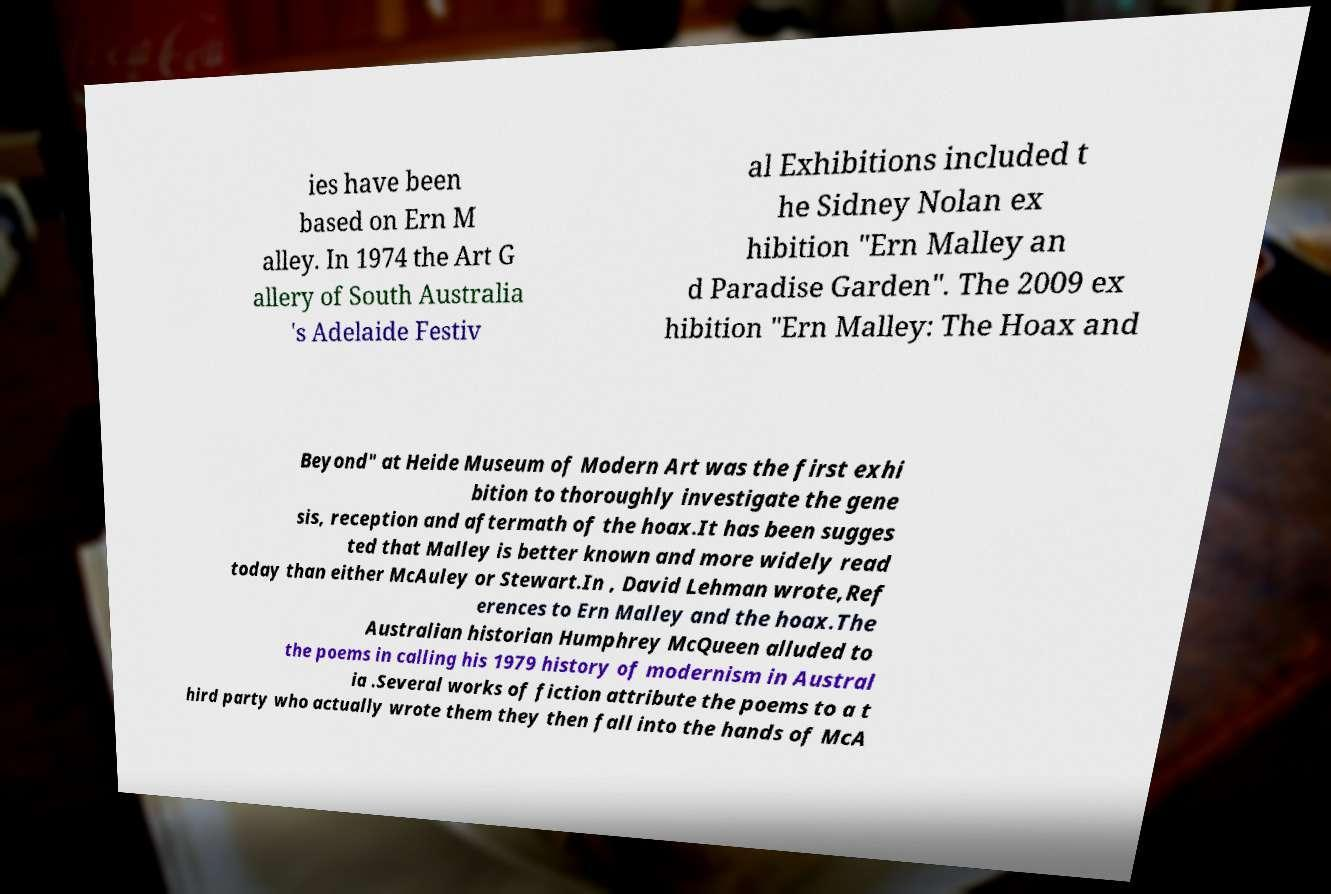There's text embedded in this image that I need extracted. Can you transcribe it verbatim? ies have been based on Ern M alley. In 1974 the Art G allery of South Australia 's Adelaide Festiv al Exhibitions included t he Sidney Nolan ex hibition "Ern Malley an d Paradise Garden". The 2009 ex hibition "Ern Malley: The Hoax and Beyond" at Heide Museum of Modern Art was the first exhi bition to thoroughly investigate the gene sis, reception and aftermath of the hoax.It has been sugges ted that Malley is better known and more widely read today than either McAuley or Stewart.In , David Lehman wrote,Ref erences to Ern Malley and the hoax.The Australian historian Humphrey McQueen alluded to the poems in calling his 1979 history of modernism in Austral ia .Several works of fiction attribute the poems to a t hird party who actually wrote them they then fall into the hands of McA 